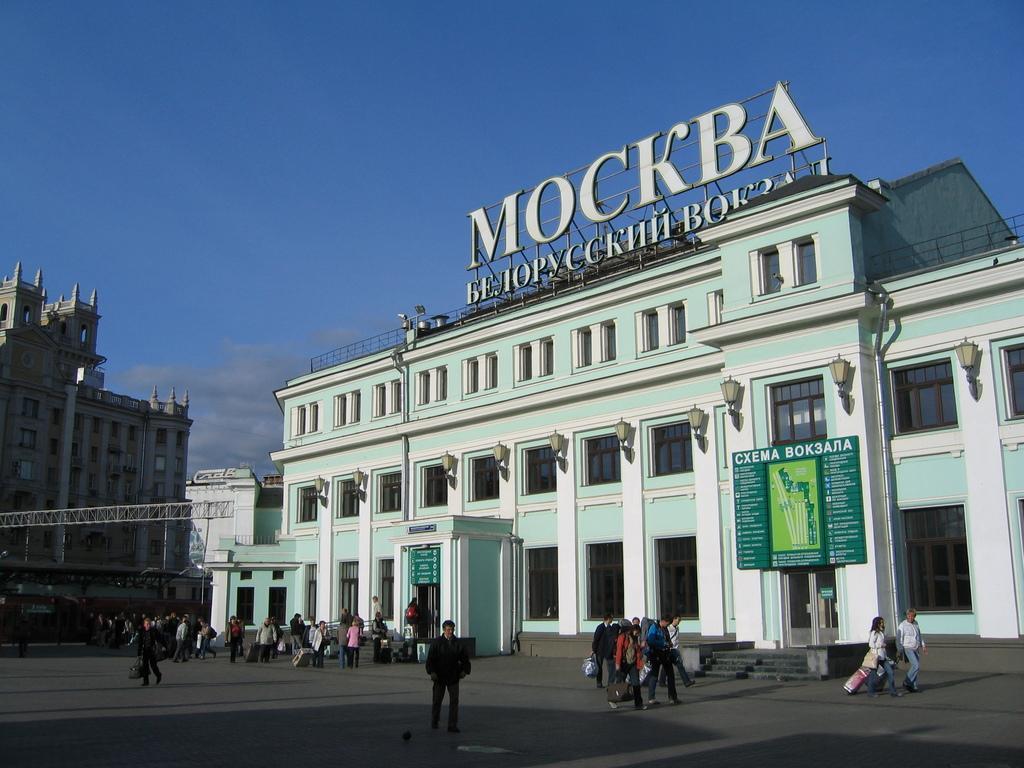Could you give a brief overview of what you see in this image? This image is taken outdoors. At the top of the image there is the sky with clouds. At the bottom of the image there is a road. In the middle of the image there are a few buildings with walls, windows, doors, pillars, railings and balconies. There are a few iron bars and there is a text. There are two boards with text on them. There are a few stairs. There are many lamps. There is a weight lifting crane. A few people are walking on the road and a few are holding luggage bags in their hands. 